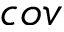<formula> <loc_0><loc_0><loc_500><loc_500>c o v</formula> 